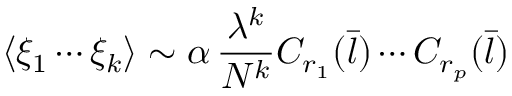<formula> <loc_0><loc_0><loc_500><loc_500>\langle \xi _ { 1 } \cdots \xi _ { k } \rangle \sim \alpha \, \frac { \lambda ^ { k } } { N ^ { k } } C _ { r _ { 1 } } ( { \bar { l } } ) \cdots C _ { r _ { p } } ( { \bar { l } } )</formula> 